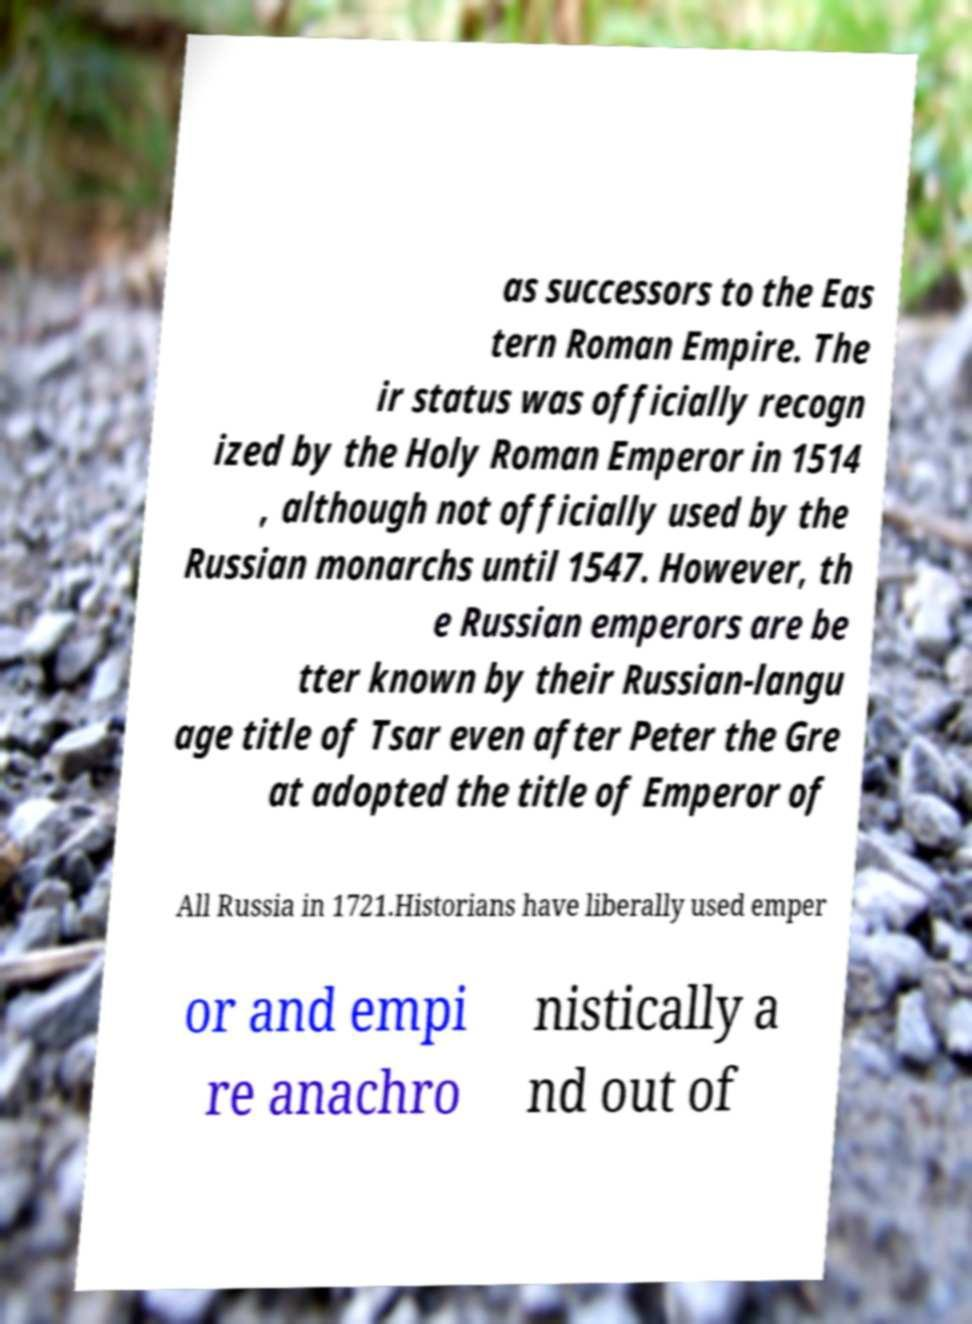Could you assist in decoding the text presented in this image and type it out clearly? as successors to the Eas tern Roman Empire. The ir status was officially recogn ized by the Holy Roman Emperor in 1514 , although not officially used by the Russian monarchs until 1547. However, th e Russian emperors are be tter known by their Russian-langu age title of Tsar even after Peter the Gre at adopted the title of Emperor of All Russia in 1721.Historians have liberally used emper or and empi re anachro nistically a nd out of 